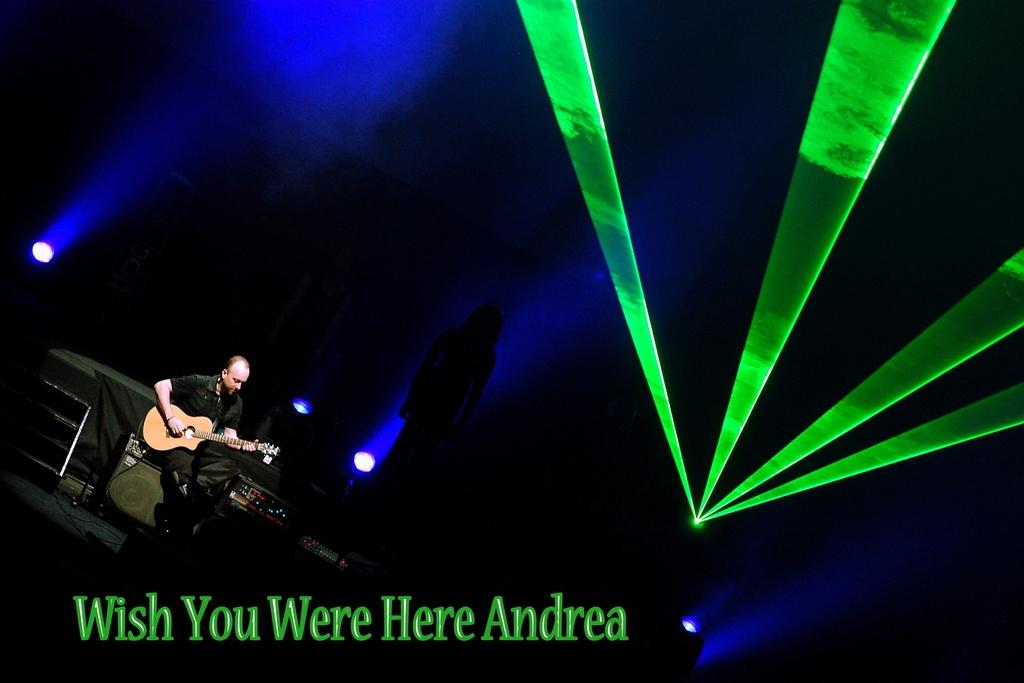What is the main subject of the image? There is a person in the image. What is the person doing in the image? The person is sitting and playing a guitar. What else can be seen in the image besides the person? There are lights visible in the image. What type of magic is the person performing with the guitar in the image? There is no indication of magic or any magical performance in the image; the person is simply playing a guitar. 